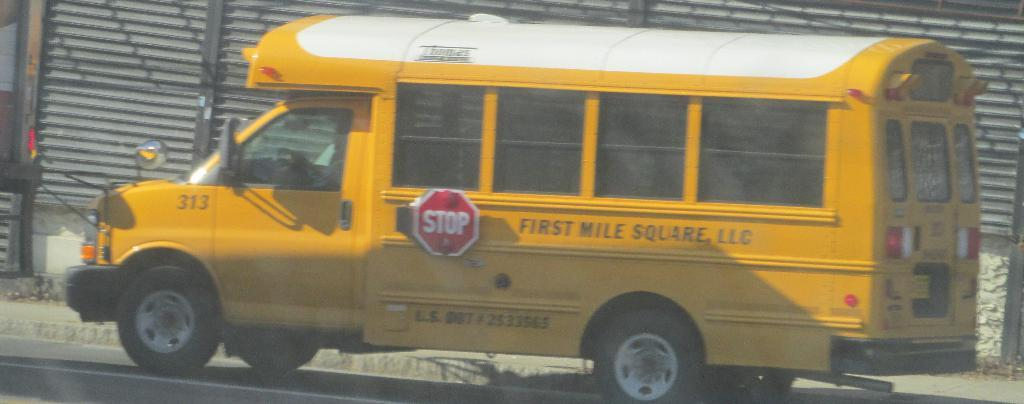What is the main feature of the image? There is a road in the image. What can be seen on the road? There is a van on the road. What is unique about the van? The van has a stop board attached to it. What is located beside the road? There is a sidewalk in the image. What can be found beside the sidewalk? There are shutters beside the sidewalk. What type of straw is being used by the pig in the image? There is no pig or straw present in the image. What is the porter carrying in the image? There is no porter present in the image. 